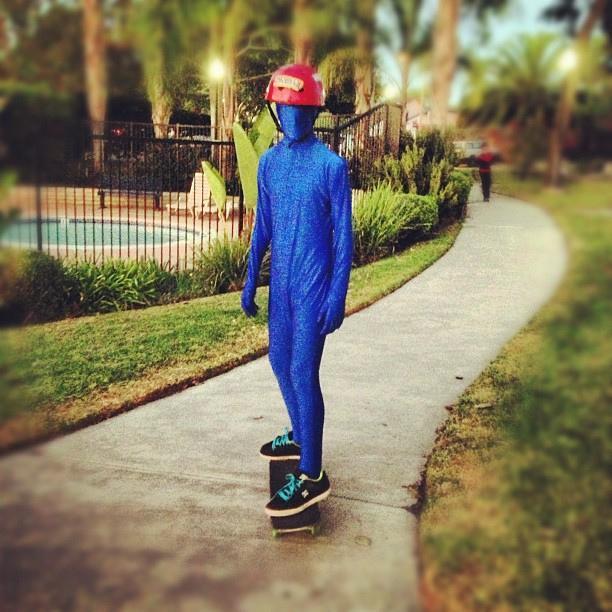How many sheep are grazing?
Give a very brief answer. 0. 